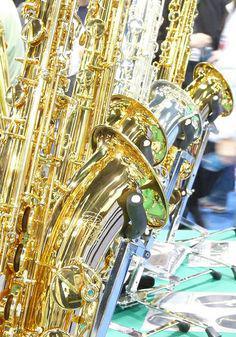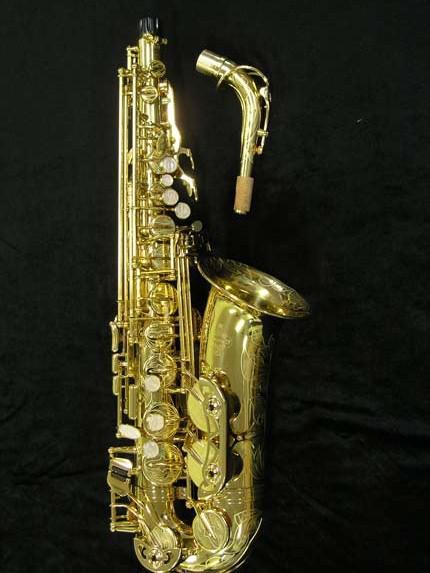The first image is the image on the left, the second image is the image on the right. For the images displayed, is the sentence "Right image shows one saxophone and left image shows one row of saxophones." factually correct? Answer yes or no. Yes. 